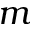Convert formula to latex. <formula><loc_0><loc_0><loc_500><loc_500>m</formula> 